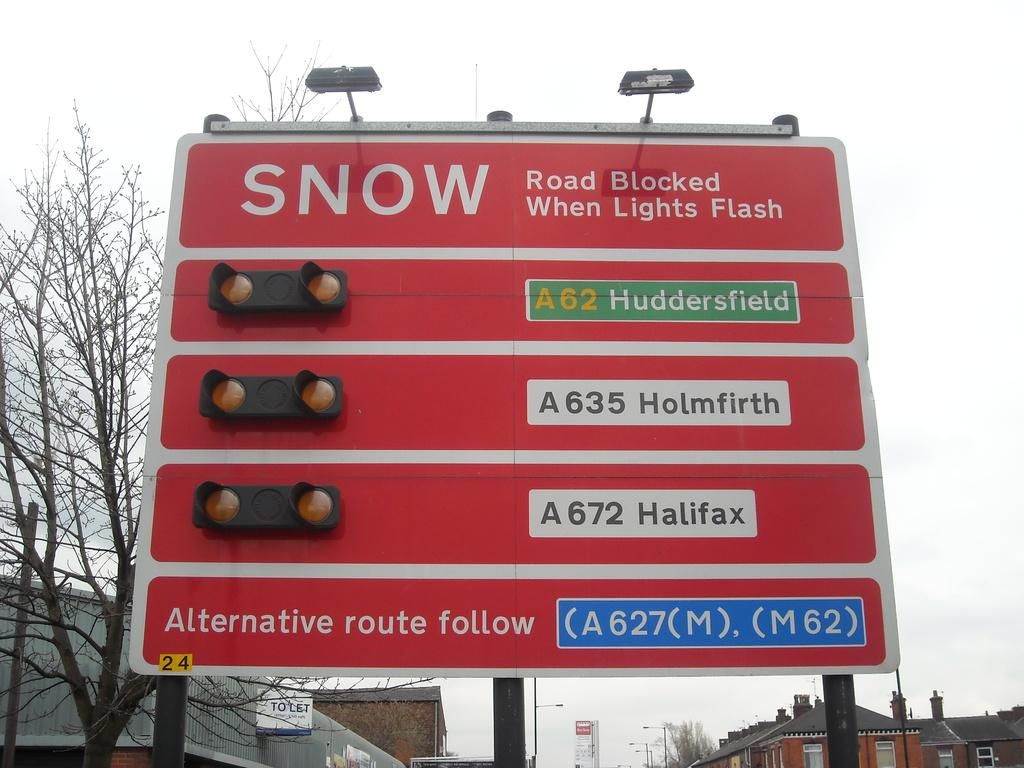Provide a one-sentence caption for the provided image. A road sign shows a warning of snow across 3 thruways. 